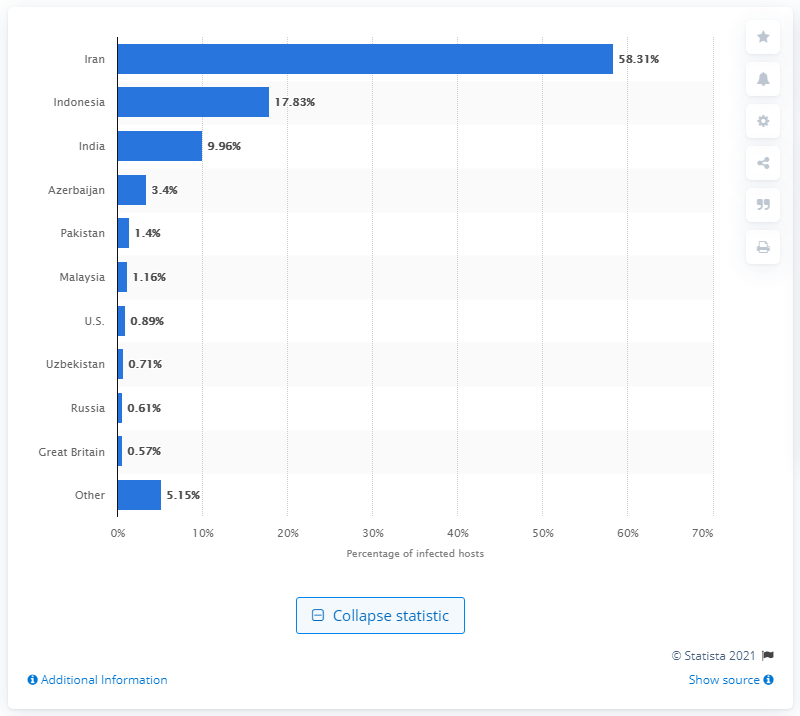Identify some key points in this picture. The report indicates that 58.31% of the infected hosts were located in Iran. 